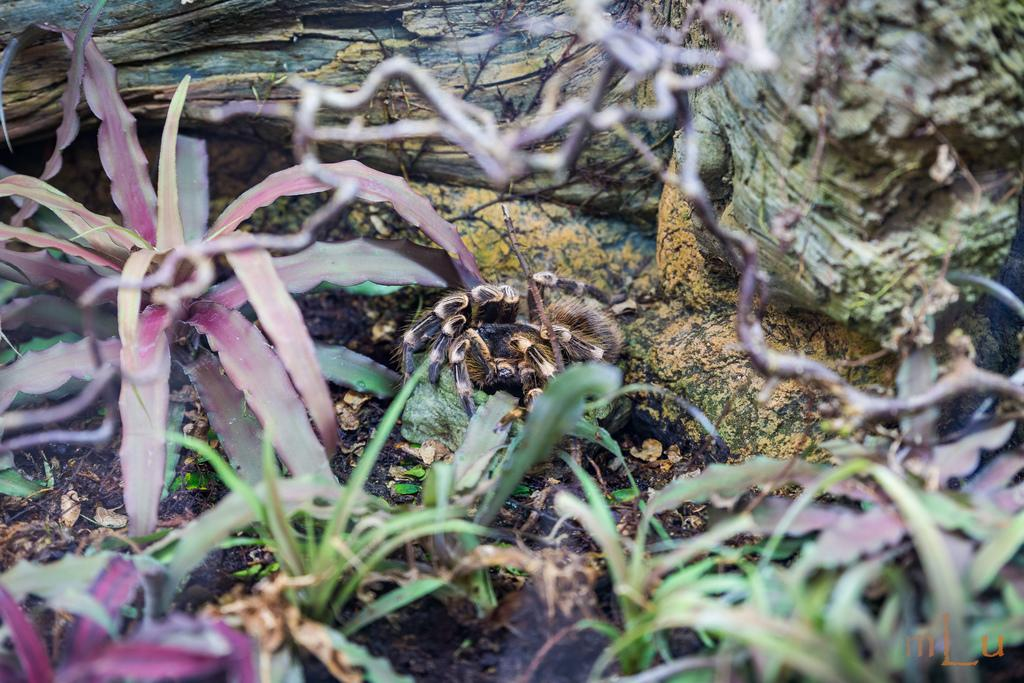What type of animal can be seen in the image? There is a spider in the image. What type of natural environment is depicted in the image? There are trees, wood, plants, and leaves visible in the image. Can you describe the location of the leaves in the image? The leaves are on the left side of the image. How many cherries are on the shelf in the image? There is no shelf or cherries present in the image. What thought is the spider having in the image? The image does not depict the spider's thoughts, as it is a still image and not capable of showing thoughts. 